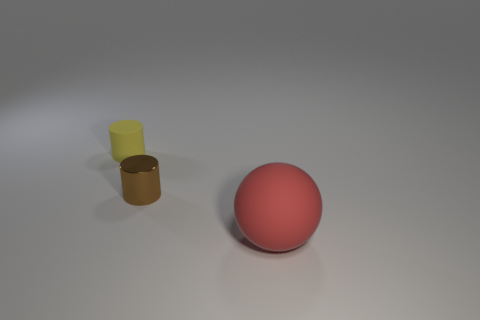How would you describe the lighting in the scene? The lighting in the scene is soft and diffused, with no harsh shadows, suggesting an overcast or studio lighting setup from above. 